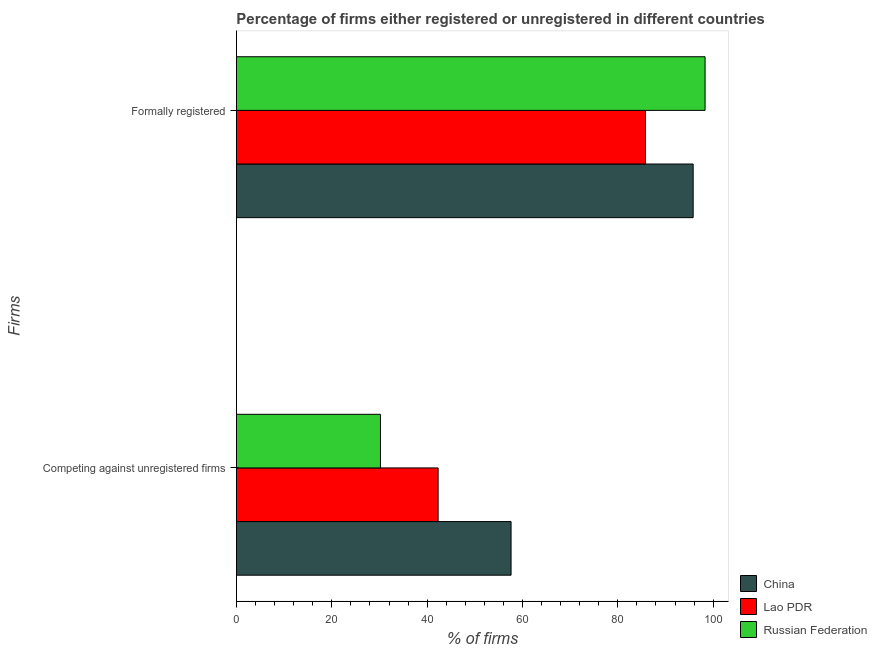How many groups of bars are there?
Offer a terse response. 2. Are the number of bars per tick equal to the number of legend labels?
Keep it short and to the point. Yes. Are the number of bars on each tick of the Y-axis equal?
Provide a succinct answer. Yes. How many bars are there on the 1st tick from the top?
Keep it short and to the point. 3. How many bars are there on the 2nd tick from the bottom?
Provide a short and direct response. 3. What is the label of the 2nd group of bars from the top?
Your answer should be very brief. Competing against unregistered firms. What is the percentage of registered firms in Russian Federation?
Ensure brevity in your answer.  30.2. Across all countries, what is the maximum percentage of formally registered firms?
Give a very brief answer. 98.3. Across all countries, what is the minimum percentage of formally registered firms?
Your answer should be very brief. 85.8. In which country was the percentage of registered firms maximum?
Give a very brief answer. China. In which country was the percentage of registered firms minimum?
Your answer should be very brief. Russian Federation. What is the total percentage of formally registered firms in the graph?
Your response must be concise. 279.9. What is the difference between the percentage of registered firms in Russian Federation and that in Lao PDR?
Ensure brevity in your answer.  -12.1. What is the difference between the percentage of registered firms in Russian Federation and the percentage of formally registered firms in China?
Your answer should be very brief. -65.6. What is the average percentage of registered firms per country?
Keep it short and to the point. 43.37. What is the difference between the percentage of formally registered firms and percentage of registered firms in Russian Federation?
Give a very brief answer. 68.1. In how many countries, is the percentage of registered firms greater than 60 %?
Your response must be concise. 0. What is the ratio of the percentage of registered firms in Lao PDR to that in China?
Provide a succinct answer. 0.73. Is the percentage of registered firms in Lao PDR less than that in Russian Federation?
Your answer should be very brief. No. What does the 1st bar from the top in Formally registered represents?
Keep it short and to the point. Russian Federation. What does the 3rd bar from the bottom in Competing against unregistered firms represents?
Offer a very short reply. Russian Federation. How many bars are there?
Offer a very short reply. 6. Are all the bars in the graph horizontal?
Your answer should be very brief. Yes. How many countries are there in the graph?
Offer a terse response. 3. Are the values on the major ticks of X-axis written in scientific E-notation?
Offer a very short reply. No. Does the graph contain grids?
Provide a short and direct response. No. What is the title of the graph?
Give a very brief answer. Percentage of firms either registered or unregistered in different countries. Does "Nepal" appear as one of the legend labels in the graph?
Offer a terse response. No. What is the label or title of the X-axis?
Make the answer very short. % of firms. What is the label or title of the Y-axis?
Your response must be concise. Firms. What is the % of firms of China in Competing against unregistered firms?
Your answer should be very brief. 57.6. What is the % of firms of Lao PDR in Competing against unregistered firms?
Provide a short and direct response. 42.3. What is the % of firms of Russian Federation in Competing against unregistered firms?
Offer a terse response. 30.2. What is the % of firms in China in Formally registered?
Ensure brevity in your answer.  95.8. What is the % of firms of Lao PDR in Formally registered?
Provide a succinct answer. 85.8. What is the % of firms of Russian Federation in Formally registered?
Your answer should be very brief. 98.3. Across all Firms, what is the maximum % of firms of China?
Provide a short and direct response. 95.8. Across all Firms, what is the maximum % of firms of Lao PDR?
Keep it short and to the point. 85.8. Across all Firms, what is the maximum % of firms in Russian Federation?
Your answer should be compact. 98.3. Across all Firms, what is the minimum % of firms in China?
Give a very brief answer. 57.6. Across all Firms, what is the minimum % of firms in Lao PDR?
Offer a very short reply. 42.3. Across all Firms, what is the minimum % of firms in Russian Federation?
Your answer should be compact. 30.2. What is the total % of firms in China in the graph?
Give a very brief answer. 153.4. What is the total % of firms in Lao PDR in the graph?
Keep it short and to the point. 128.1. What is the total % of firms of Russian Federation in the graph?
Offer a terse response. 128.5. What is the difference between the % of firms of China in Competing against unregistered firms and that in Formally registered?
Your answer should be very brief. -38.2. What is the difference between the % of firms in Lao PDR in Competing against unregistered firms and that in Formally registered?
Keep it short and to the point. -43.5. What is the difference between the % of firms of Russian Federation in Competing against unregistered firms and that in Formally registered?
Make the answer very short. -68.1. What is the difference between the % of firms in China in Competing against unregistered firms and the % of firms in Lao PDR in Formally registered?
Your answer should be compact. -28.2. What is the difference between the % of firms of China in Competing against unregistered firms and the % of firms of Russian Federation in Formally registered?
Ensure brevity in your answer.  -40.7. What is the difference between the % of firms in Lao PDR in Competing against unregistered firms and the % of firms in Russian Federation in Formally registered?
Provide a short and direct response. -56. What is the average % of firms of China per Firms?
Give a very brief answer. 76.7. What is the average % of firms of Lao PDR per Firms?
Keep it short and to the point. 64.05. What is the average % of firms in Russian Federation per Firms?
Make the answer very short. 64.25. What is the difference between the % of firms in China and % of firms in Lao PDR in Competing against unregistered firms?
Give a very brief answer. 15.3. What is the difference between the % of firms of China and % of firms of Russian Federation in Competing against unregistered firms?
Your answer should be very brief. 27.4. What is the ratio of the % of firms in China in Competing against unregistered firms to that in Formally registered?
Give a very brief answer. 0.6. What is the ratio of the % of firms of Lao PDR in Competing against unregistered firms to that in Formally registered?
Ensure brevity in your answer.  0.49. What is the ratio of the % of firms of Russian Federation in Competing against unregistered firms to that in Formally registered?
Provide a short and direct response. 0.31. What is the difference between the highest and the second highest % of firms in China?
Ensure brevity in your answer.  38.2. What is the difference between the highest and the second highest % of firms in Lao PDR?
Provide a short and direct response. 43.5. What is the difference between the highest and the second highest % of firms of Russian Federation?
Your answer should be compact. 68.1. What is the difference between the highest and the lowest % of firms of China?
Provide a succinct answer. 38.2. What is the difference between the highest and the lowest % of firms of Lao PDR?
Offer a very short reply. 43.5. What is the difference between the highest and the lowest % of firms of Russian Federation?
Ensure brevity in your answer.  68.1. 